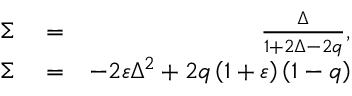Convert formula to latex. <formula><loc_0><loc_0><loc_500><loc_500>\begin{array} { r l r } { \Sigma } & = } & { \frac { \Delta } { 1 + 2 \Delta - 2 q } , } \\ { \Sigma } & = } & { - 2 \varepsilon \Delta ^ { 2 } + 2 q \left ( 1 + \varepsilon \right ) \left ( 1 - q \right ) } \end{array}</formula> 